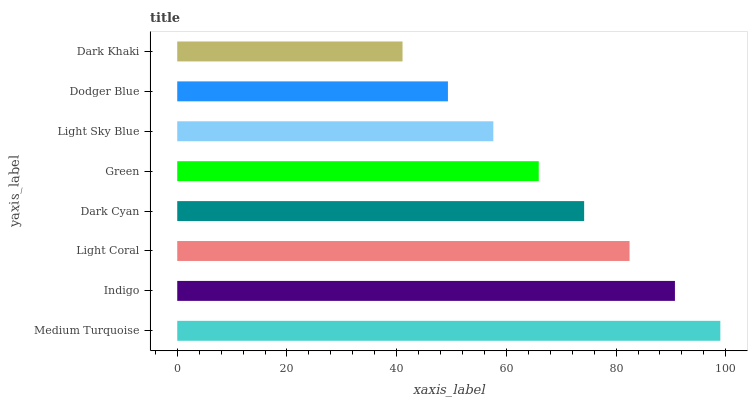Is Dark Khaki the minimum?
Answer yes or no. Yes. Is Medium Turquoise the maximum?
Answer yes or no. Yes. Is Indigo the minimum?
Answer yes or no. No. Is Indigo the maximum?
Answer yes or no. No. Is Medium Turquoise greater than Indigo?
Answer yes or no. Yes. Is Indigo less than Medium Turquoise?
Answer yes or no. Yes. Is Indigo greater than Medium Turquoise?
Answer yes or no. No. Is Medium Turquoise less than Indigo?
Answer yes or no. No. Is Dark Cyan the high median?
Answer yes or no. Yes. Is Green the low median?
Answer yes or no. Yes. Is Indigo the high median?
Answer yes or no. No. Is Dark Cyan the low median?
Answer yes or no. No. 